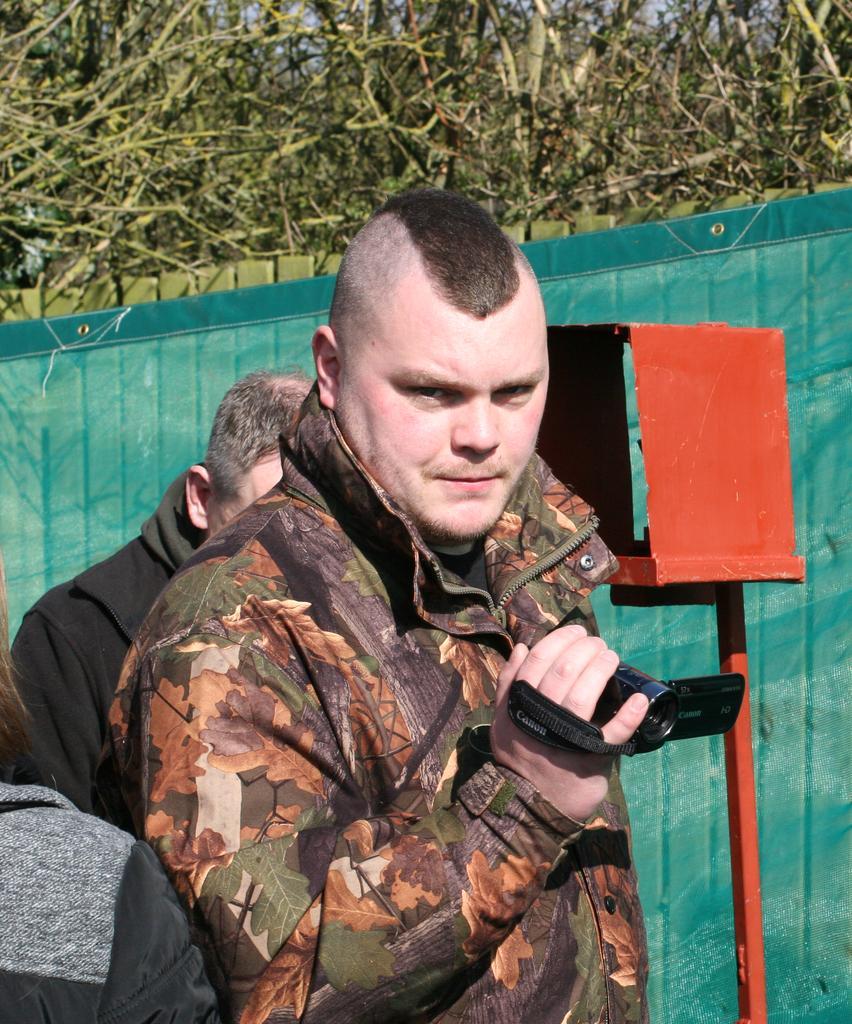Please provide a concise description of this image. In the middle of the image, there is a person in a jacket, holding a camera with one hand. Beside him, there are two persons. On the right side, there is a red color pole. In the background, there is a green color sheet and there are trees. 